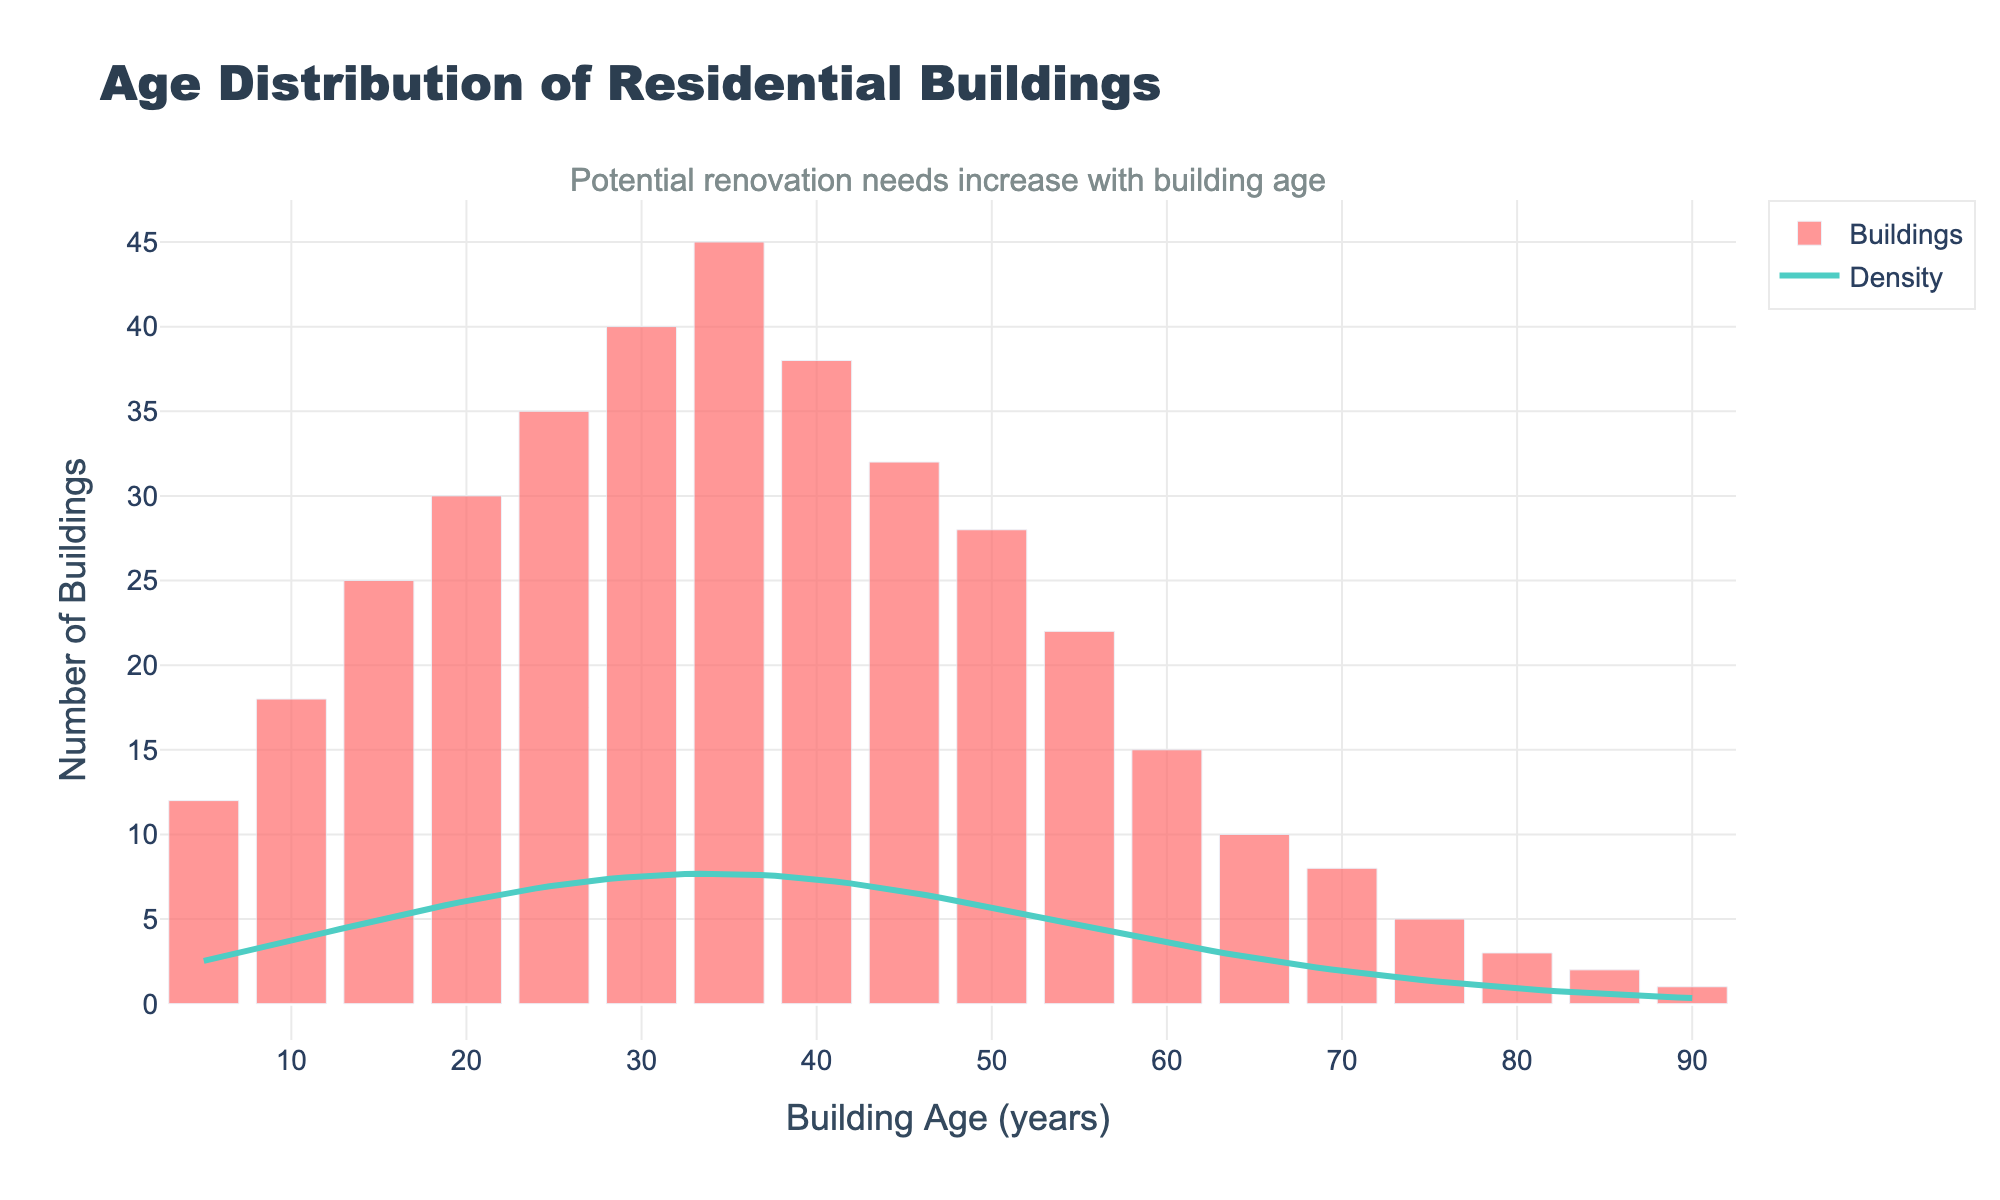what is the title of the figure? The title of a figure is usually located at the top center of the plot and provides a brief description of what the plot represents. In this case, it reads "Age Distribution of Residential Buildings".
Answer: Age Distribution of Residential Buildings what is on the x-axis? The x-axis usually represents the independent variable, and in this case, it indicates the age of the buildings in years. This can be inferred from the x-axis label.
Answer: Building Age (years) how many buildings are in the area? To find the total number of buildings, we need to sum up all the numbers in the y-axis, which indicates the number of buildings for each age group. Summing them all gives the total number.
Answer: 399 which age group has the highest number of buildings? By examining the histogram, the bar with the highest height represents the age group with the most buildings. The highest bar corresponds to the age group of 35 years.
Answer: 35 years how many buildings are over 50 years old? To determine this, sum the number of buildings for all age groups over 50 years. These include 55, 60, 65, 70, 75, 80, 85, and 90-year-old buildings.
Answer: 66 which building age group shows a noticeable drop in number? By observing the histogram, we can see that there is a considerable decrease in the height of bars after around 40 years of age.
Answer: After 40 years what does the density curve represent in the figure? The density curve (KDE) represents the probability density function of the building ages, giving a sense of the distribution of the buildings across different ages.
Answer: Probability density function of building ages what could be inferred about renovation needs based on the distribution? Older buildings likely need more renovations due to wear and tear. The histogram shows a significant number of buildings around 35 to 50 years old, indicating potential high renovation needs.
Answer: High renovation needs around 35-50 years how does the number of buildings in the age group 30 years compare to the age group 60 years? Looking at the height of the bars for these age groups, we see that there are more buildings at 30 years of age than at 60 years.
Answer: More buildings at 30 years than 60 years what is the trend in the number of buildings as age increases? The histogram shows an increasing number of buildings up to around 35 years, after which the count starts to decrease as the age increases.
Answer: Increase up to 35 years, then decrease 